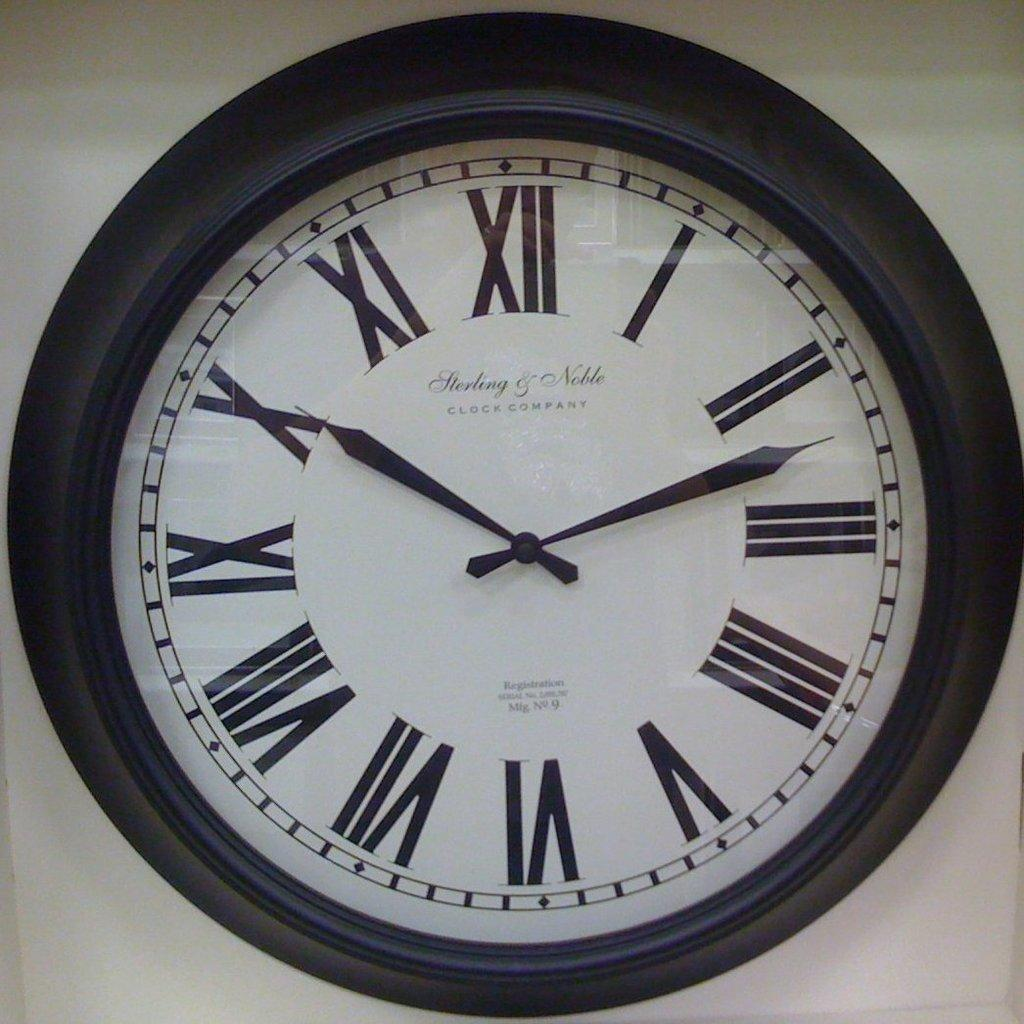<image>
Describe the image concisely. A black framed clock with roman numerals for numbers. 